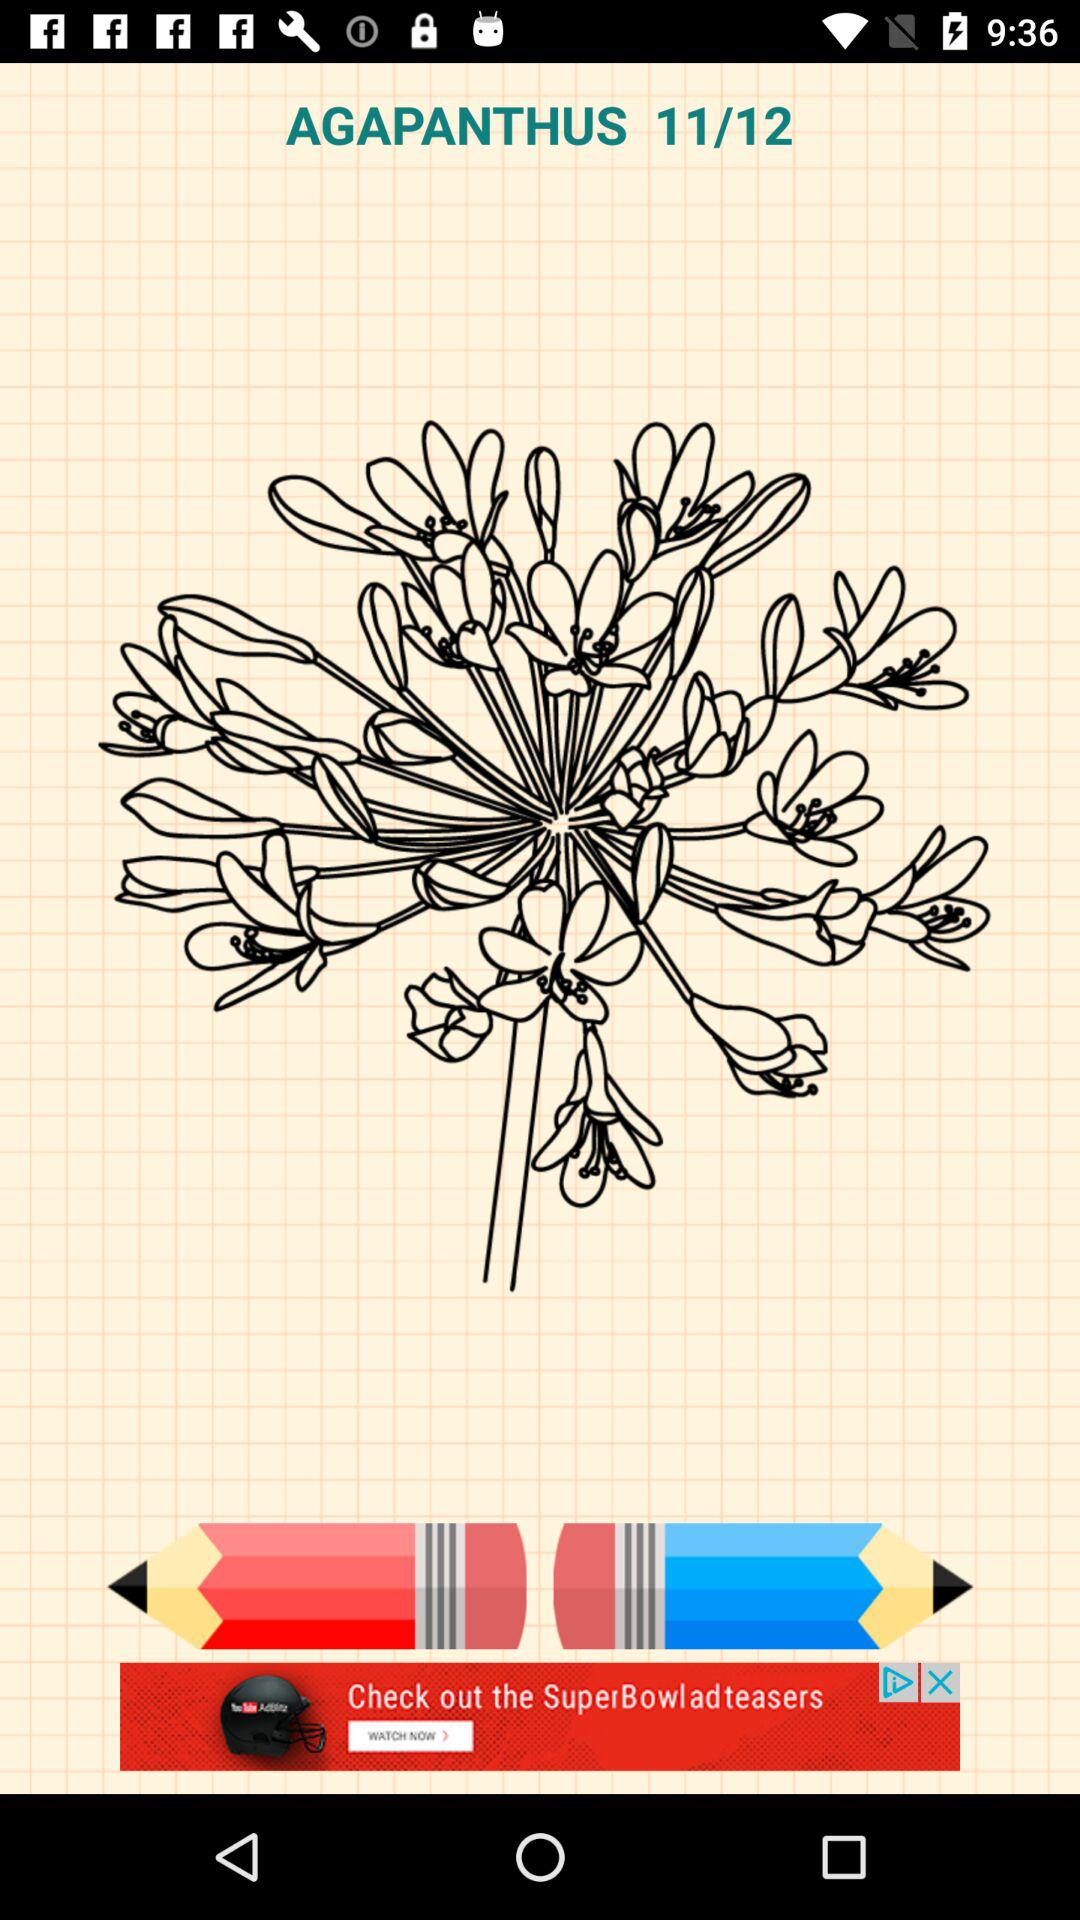At which image number am I? You are at image number 11. 